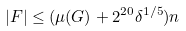Convert formula to latex. <formula><loc_0><loc_0><loc_500><loc_500>| F | \leq ( \mu ( G ) + 2 ^ { 2 0 } \delta ^ { 1 / 5 } ) n</formula> 